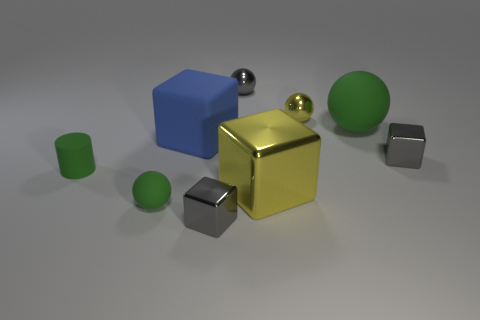Subtract all yellow metal balls. How many balls are left? 3 Add 1 large rubber blocks. How many objects exist? 10 Subtract all green balls. How many balls are left? 2 Subtract 1 green balls. How many objects are left? 8 Subtract all blocks. How many objects are left? 5 Subtract 3 balls. How many balls are left? 1 Subtract all brown cubes. Subtract all gray balls. How many cubes are left? 4 Subtract all red blocks. How many yellow spheres are left? 1 Subtract all large shiny things. Subtract all gray things. How many objects are left? 5 Add 6 small green balls. How many small green balls are left? 7 